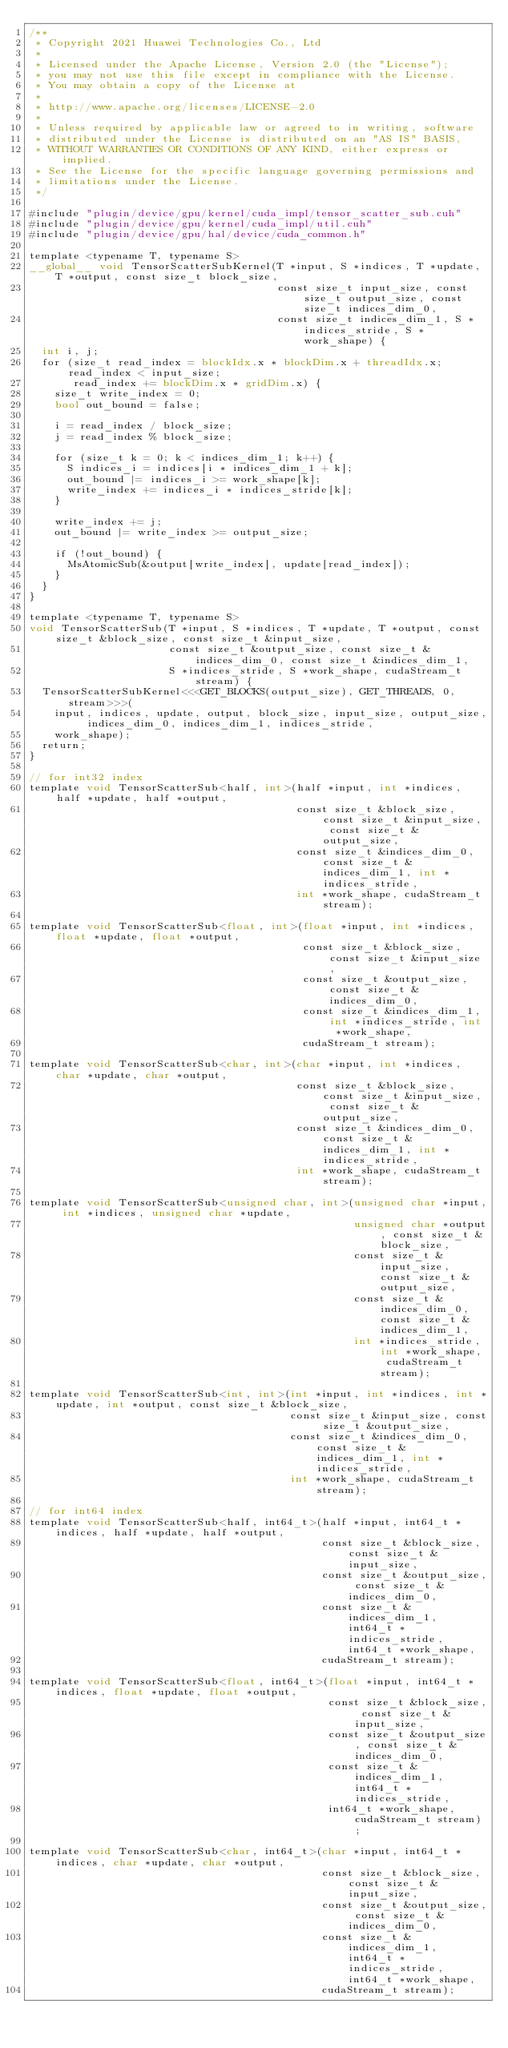<code> <loc_0><loc_0><loc_500><loc_500><_Cuda_>/**
 * Copyright 2021 Huawei Technologies Co., Ltd
 *
 * Licensed under the Apache License, Version 2.0 (the "License");
 * you may not use this file except in compliance with the License.
 * You may obtain a copy of the License at
 *
 * http://www.apache.org/licenses/LICENSE-2.0
 *
 * Unless required by applicable law or agreed to in writing, software
 * distributed under the License is distributed on an "AS IS" BASIS,
 * WITHOUT WARRANTIES OR CONDITIONS OF ANY KIND, either express or implied.
 * See the License for the specific language governing permissions and
 * limitations under the License.
 */

#include "plugin/device/gpu/kernel/cuda_impl/tensor_scatter_sub.cuh"
#include "plugin/device/gpu/kernel/cuda_impl/util.cuh"
#include "plugin/device/gpu/hal/device/cuda_common.h"

template <typename T, typename S>
__global__ void TensorScatterSubKernel(T *input, S *indices, T *update, T *output, const size_t block_size,
                                       const size_t input_size, const size_t output_size, const size_t indices_dim_0,
                                       const size_t indices_dim_1, S *indices_stride, S *work_shape) {
  int i, j;
  for (size_t read_index = blockIdx.x * blockDim.x + threadIdx.x; read_index < input_size;
       read_index += blockDim.x * gridDim.x) {
    size_t write_index = 0;
    bool out_bound = false;

    i = read_index / block_size;
    j = read_index % block_size;

    for (size_t k = 0; k < indices_dim_1; k++) {
      S indices_i = indices[i * indices_dim_1 + k];
      out_bound |= indices_i >= work_shape[k];
      write_index += indices_i * indices_stride[k];
    }

    write_index += j;
    out_bound |= write_index >= output_size;

    if (!out_bound) {
      MsAtomicSub(&output[write_index], update[read_index]);
    }
  }
}

template <typename T, typename S>
void TensorScatterSub(T *input, S *indices, T *update, T *output, const size_t &block_size, const size_t &input_size,
                      const size_t &output_size, const size_t &indices_dim_0, const size_t &indices_dim_1,
                      S *indices_stride, S *work_shape, cudaStream_t stream) {
  TensorScatterSubKernel<<<GET_BLOCKS(output_size), GET_THREADS, 0, stream>>>(
    input, indices, update, output, block_size, input_size, output_size, indices_dim_0, indices_dim_1, indices_stride,
    work_shape);
  return;
}

// for int32 index
template void TensorScatterSub<half, int>(half *input, int *indices, half *update, half *output,
                                          const size_t &block_size, const size_t &input_size, const size_t &output_size,
                                          const size_t &indices_dim_0, const size_t &indices_dim_1, int *indices_stride,
                                          int *work_shape, cudaStream_t stream);

template void TensorScatterSub<float, int>(float *input, int *indices, float *update, float *output,
                                           const size_t &block_size, const size_t &input_size,
                                           const size_t &output_size, const size_t &indices_dim_0,
                                           const size_t &indices_dim_1, int *indices_stride, int *work_shape,
                                           cudaStream_t stream);

template void TensorScatterSub<char, int>(char *input, int *indices, char *update, char *output,
                                          const size_t &block_size, const size_t &input_size, const size_t &output_size,
                                          const size_t &indices_dim_0, const size_t &indices_dim_1, int *indices_stride,
                                          int *work_shape, cudaStream_t stream);

template void TensorScatterSub<unsigned char, int>(unsigned char *input, int *indices, unsigned char *update,
                                                   unsigned char *output, const size_t &block_size,
                                                   const size_t &input_size, const size_t &output_size,
                                                   const size_t &indices_dim_0, const size_t &indices_dim_1,
                                                   int *indices_stride, int *work_shape, cudaStream_t stream);

template void TensorScatterSub<int, int>(int *input, int *indices, int *update, int *output, const size_t &block_size,
                                         const size_t &input_size, const size_t &output_size,
                                         const size_t &indices_dim_0, const size_t &indices_dim_1, int *indices_stride,
                                         int *work_shape, cudaStream_t stream);

// for int64 index
template void TensorScatterSub<half, int64_t>(half *input, int64_t *indices, half *update, half *output,
                                              const size_t &block_size, const size_t &input_size,
                                              const size_t &output_size, const size_t &indices_dim_0,
                                              const size_t &indices_dim_1, int64_t *indices_stride, int64_t *work_shape,
                                              cudaStream_t stream);

template void TensorScatterSub<float, int64_t>(float *input, int64_t *indices, float *update, float *output,
                                               const size_t &block_size, const size_t &input_size,
                                               const size_t &output_size, const size_t &indices_dim_0,
                                               const size_t &indices_dim_1, int64_t *indices_stride,
                                               int64_t *work_shape, cudaStream_t stream);

template void TensorScatterSub<char, int64_t>(char *input, int64_t *indices, char *update, char *output,
                                              const size_t &block_size, const size_t &input_size,
                                              const size_t &output_size, const size_t &indices_dim_0,
                                              const size_t &indices_dim_1, int64_t *indices_stride, int64_t *work_shape,
                                              cudaStream_t stream);
</code> 